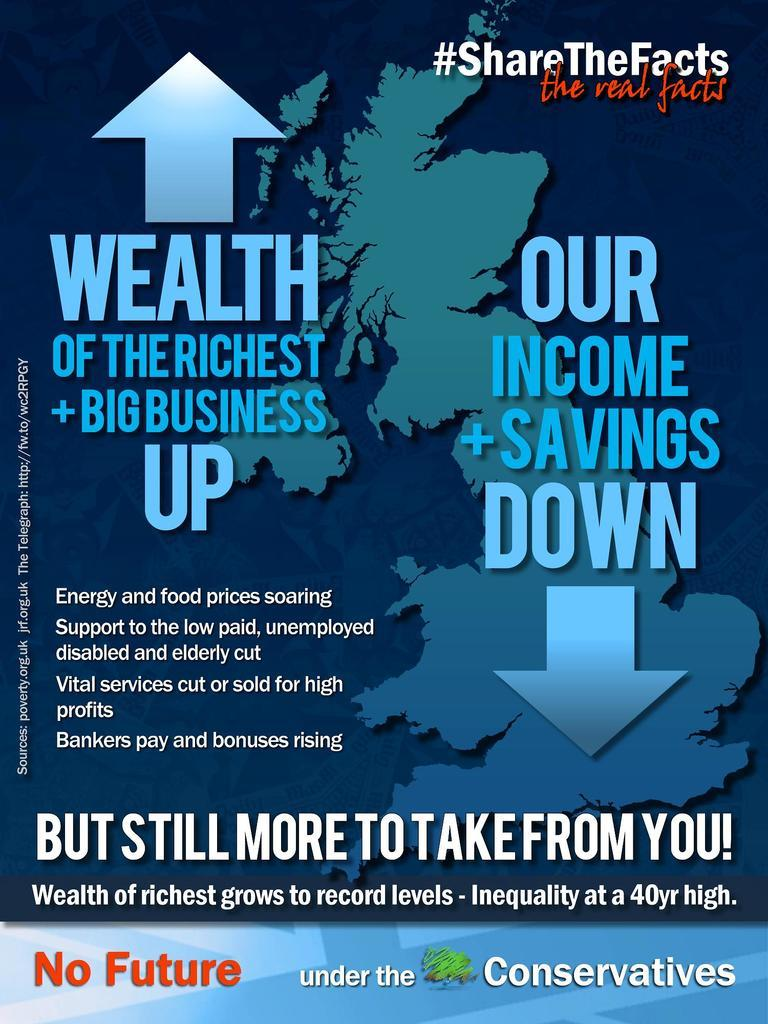<image>
Offer a succinct explanation of the picture presented. a poster with the words share the facts in the top right 